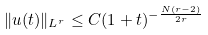<formula> <loc_0><loc_0><loc_500><loc_500>\| u ( t ) \| _ { L ^ { r } } \leq C ( 1 + t ) ^ { - \frac { N ( r - 2 ) } { 2 r } }</formula> 